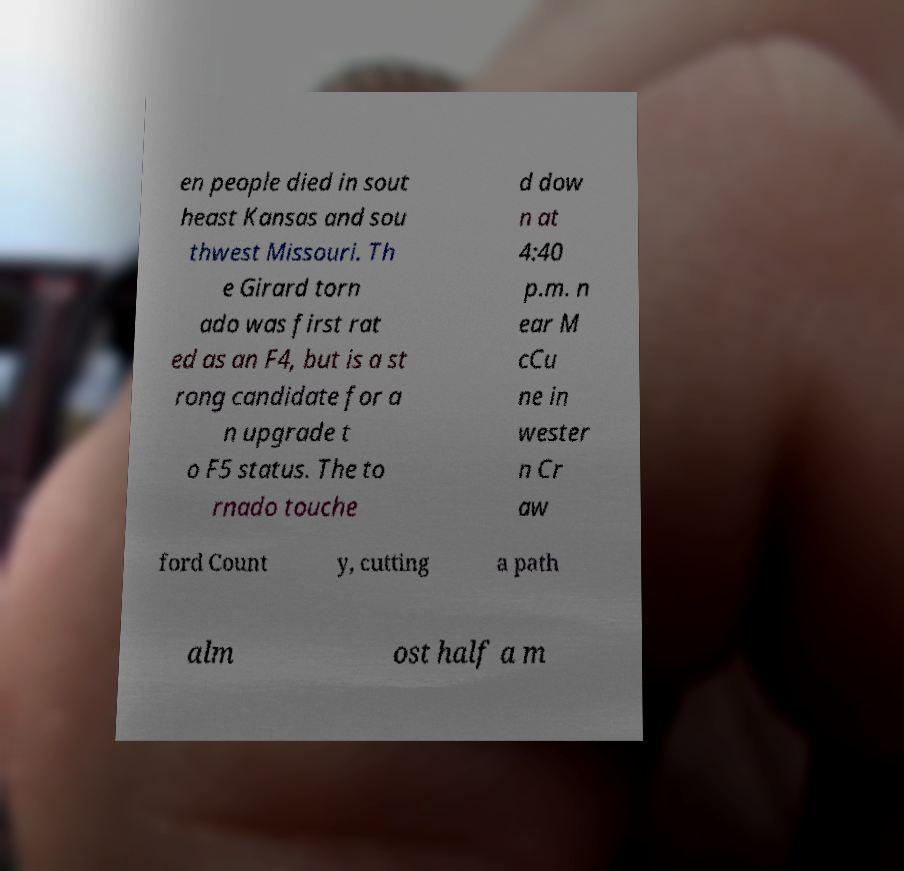Could you extract and type out the text from this image? en people died in sout heast Kansas and sou thwest Missouri. Th e Girard torn ado was first rat ed as an F4, but is a st rong candidate for a n upgrade t o F5 status. The to rnado touche d dow n at 4:40 p.m. n ear M cCu ne in wester n Cr aw ford Count y, cutting a path alm ost half a m 